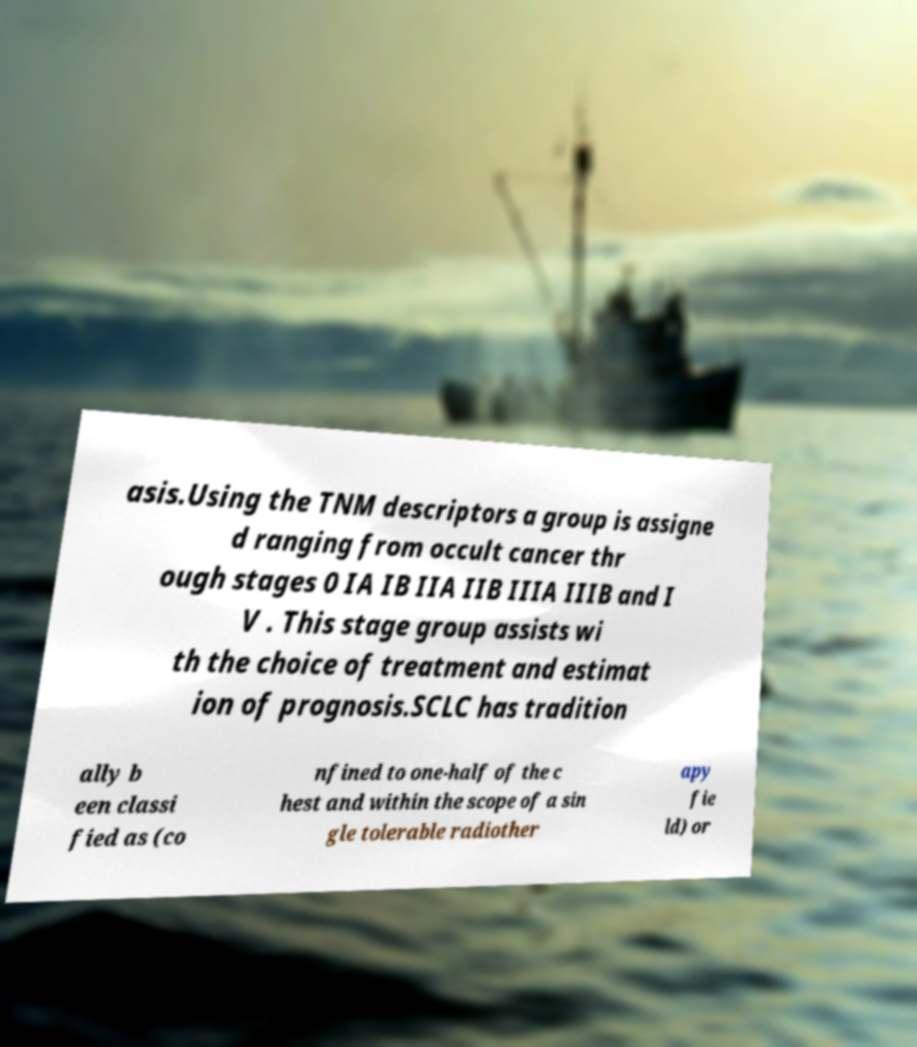Please identify and transcribe the text found in this image. asis.Using the TNM descriptors a group is assigne d ranging from occult cancer thr ough stages 0 IA IB IIA IIB IIIA IIIB and I V . This stage group assists wi th the choice of treatment and estimat ion of prognosis.SCLC has tradition ally b een classi fied as (co nfined to one-half of the c hest and within the scope of a sin gle tolerable radiother apy fie ld) or 